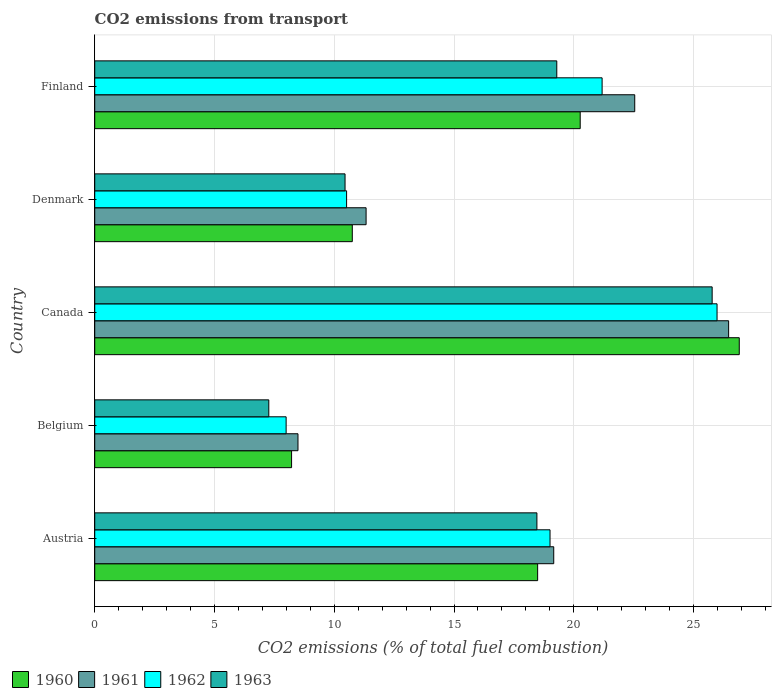How many different coloured bars are there?
Offer a very short reply. 4. Are the number of bars per tick equal to the number of legend labels?
Keep it short and to the point. Yes. Are the number of bars on each tick of the Y-axis equal?
Your answer should be very brief. Yes. What is the label of the 3rd group of bars from the top?
Your answer should be very brief. Canada. In how many cases, is the number of bars for a given country not equal to the number of legend labels?
Keep it short and to the point. 0. What is the total CO2 emitted in 1962 in Finland?
Provide a succinct answer. 21.18. Across all countries, what is the maximum total CO2 emitted in 1960?
Make the answer very short. 26.91. Across all countries, what is the minimum total CO2 emitted in 1962?
Your response must be concise. 7.99. In which country was the total CO2 emitted in 1961 minimum?
Your answer should be very brief. Belgium. What is the total total CO2 emitted in 1962 in the graph?
Provide a short and direct response. 84.67. What is the difference between the total CO2 emitted in 1961 in Austria and that in Denmark?
Provide a short and direct response. 7.83. What is the difference between the total CO2 emitted in 1963 in Austria and the total CO2 emitted in 1961 in Finland?
Ensure brevity in your answer.  -4.08. What is the average total CO2 emitted in 1961 per country?
Give a very brief answer. 17.6. What is the difference between the total CO2 emitted in 1963 and total CO2 emitted in 1960 in Finland?
Keep it short and to the point. -0.98. In how many countries, is the total CO2 emitted in 1963 greater than 26 ?
Make the answer very short. 0. What is the ratio of the total CO2 emitted in 1963 in Belgium to that in Denmark?
Provide a succinct answer. 0.7. Is the difference between the total CO2 emitted in 1963 in Belgium and Canada greater than the difference between the total CO2 emitted in 1960 in Belgium and Canada?
Ensure brevity in your answer.  Yes. What is the difference between the highest and the second highest total CO2 emitted in 1962?
Your response must be concise. 4.8. What is the difference between the highest and the lowest total CO2 emitted in 1963?
Give a very brief answer. 18.51. What does the 3rd bar from the bottom in Austria represents?
Provide a short and direct response. 1962. Is it the case that in every country, the sum of the total CO2 emitted in 1961 and total CO2 emitted in 1963 is greater than the total CO2 emitted in 1962?
Provide a succinct answer. Yes. How many bars are there?
Offer a very short reply. 20. Are all the bars in the graph horizontal?
Provide a succinct answer. Yes. How many countries are there in the graph?
Your answer should be very brief. 5. Does the graph contain any zero values?
Provide a short and direct response. No. Does the graph contain grids?
Provide a short and direct response. Yes. Where does the legend appear in the graph?
Provide a short and direct response. Bottom left. How are the legend labels stacked?
Provide a succinct answer. Horizontal. What is the title of the graph?
Offer a terse response. CO2 emissions from transport. Does "2000" appear as one of the legend labels in the graph?
Provide a short and direct response. No. What is the label or title of the X-axis?
Ensure brevity in your answer.  CO2 emissions (% of total fuel combustion). What is the CO2 emissions (% of total fuel combustion) in 1960 in Austria?
Give a very brief answer. 18.49. What is the CO2 emissions (% of total fuel combustion) in 1961 in Austria?
Offer a very short reply. 19.16. What is the CO2 emissions (% of total fuel combustion) in 1962 in Austria?
Ensure brevity in your answer.  19.01. What is the CO2 emissions (% of total fuel combustion) in 1963 in Austria?
Offer a terse response. 18.46. What is the CO2 emissions (% of total fuel combustion) in 1960 in Belgium?
Your answer should be very brief. 8.22. What is the CO2 emissions (% of total fuel combustion) of 1961 in Belgium?
Keep it short and to the point. 8.49. What is the CO2 emissions (% of total fuel combustion) in 1962 in Belgium?
Offer a very short reply. 7.99. What is the CO2 emissions (% of total fuel combustion) of 1963 in Belgium?
Provide a short and direct response. 7.27. What is the CO2 emissions (% of total fuel combustion) in 1960 in Canada?
Your answer should be compact. 26.91. What is the CO2 emissions (% of total fuel combustion) of 1961 in Canada?
Offer a very short reply. 26.46. What is the CO2 emissions (% of total fuel combustion) of 1962 in Canada?
Keep it short and to the point. 25.98. What is the CO2 emissions (% of total fuel combustion) of 1963 in Canada?
Your answer should be compact. 25.78. What is the CO2 emissions (% of total fuel combustion) of 1960 in Denmark?
Ensure brevity in your answer.  10.75. What is the CO2 emissions (% of total fuel combustion) of 1961 in Denmark?
Your response must be concise. 11.33. What is the CO2 emissions (% of total fuel combustion) in 1962 in Denmark?
Your answer should be very brief. 10.51. What is the CO2 emissions (% of total fuel combustion) of 1963 in Denmark?
Keep it short and to the point. 10.45. What is the CO2 emissions (% of total fuel combustion) in 1960 in Finland?
Make the answer very short. 20.27. What is the CO2 emissions (% of total fuel combustion) in 1961 in Finland?
Provide a succinct answer. 22.54. What is the CO2 emissions (% of total fuel combustion) in 1962 in Finland?
Offer a very short reply. 21.18. What is the CO2 emissions (% of total fuel combustion) of 1963 in Finland?
Offer a very short reply. 19.29. Across all countries, what is the maximum CO2 emissions (% of total fuel combustion) in 1960?
Offer a very short reply. 26.91. Across all countries, what is the maximum CO2 emissions (% of total fuel combustion) of 1961?
Provide a succinct answer. 26.46. Across all countries, what is the maximum CO2 emissions (% of total fuel combustion) in 1962?
Offer a very short reply. 25.98. Across all countries, what is the maximum CO2 emissions (% of total fuel combustion) of 1963?
Give a very brief answer. 25.78. Across all countries, what is the minimum CO2 emissions (% of total fuel combustion) of 1960?
Your response must be concise. 8.22. Across all countries, what is the minimum CO2 emissions (% of total fuel combustion) in 1961?
Make the answer very short. 8.49. Across all countries, what is the minimum CO2 emissions (% of total fuel combustion) in 1962?
Offer a terse response. 7.99. Across all countries, what is the minimum CO2 emissions (% of total fuel combustion) in 1963?
Your answer should be compact. 7.27. What is the total CO2 emissions (% of total fuel combustion) of 1960 in the graph?
Offer a very short reply. 84.64. What is the total CO2 emissions (% of total fuel combustion) of 1961 in the graph?
Keep it short and to the point. 87.98. What is the total CO2 emissions (% of total fuel combustion) in 1962 in the graph?
Keep it short and to the point. 84.67. What is the total CO2 emissions (% of total fuel combustion) in 1963 in the graph?
Ensure brevity in your answer.  81.24. What is the difference between the CO2 emissions (% of total fuel combustion) of 1960 in Austria and that in Belgium?
Offer a terse response. 10.27. What is the difference between the CO2 emissions (% of total fuel combustion) of 1961 in Austria and that in Belgium?
Your response must be concise. 10.68. What is the difference between the CO2 emissions (% of total fuel combustion) of 1962 in Austria and that in Belgium?
Provide a succinct answer. 11.02. What is the difference between the CO2 emissions (% of total fuel combustion) of 1963 in Austria and that in Belgium?
Your answer should be very brief. 11.19. What is the difference between the CO2 emissions (% of total fuel combustion) in 1960 in Austria and that in Canada?
Provide a succinct answer. -8.42. What is the difference between the CO2 emissions (% of total fuel combustion) of 1961 in Austria and that in Canada?
Your response must be concise. -7.3. What is the difference between the CO2 emissions (% of total fuel combustion) in 1962 in Austria and that in Canada?
Provide a short and direct response. -6.97. What is the difference between the CO2 emissions (% of total fuel combustion) of 1963 in Austria and that in Canada?
Make the answer very short. -7.32. What is the difference between the CO2 emissions (% of total fuel combustion) of 1960 in Austria and that in Denmark?
Offer a very short reply. 7.74. What is the difference between the CO2 emissions (% of total fuel combustion) in 1961 in Austria and that in Denmark?
Your response must be concise. 7.83. What is the difference between the CO2 emissions (% of total fuel combustion) of 1962 in Austria and that in Denmark?
Your answer should be compact. 8.49. What is the difference between the CO2 emissions (% of total fuel combustion) of 1963 in Austria and that in Denmark?
Your response must be concise. 8.01. What is the difference between the CO2 emissions (% of total fuel combustion) of 1960 in Austria and that in Finland?
Your answer should be very brief. -1.78. What is the difference between the CO2 emissions (% of total fuel combustion) in 1961 in Austria and that in Finland?
Offer a terse response. -3.38. What is the difference between the CO2 emissions (% of total fuel combustion) in 1962 in Austria and that in Finland?
Provide a succinct answer. -2.17. What is the difference between the CO2 emissions (% of total fuel combustion) of 1963 in Austria and that in Finland?
Give a very brief answer. -0.83. What is the difference between the CO2 emissions (% of total fuel combustion) in 1960 in Belgium and that in Canada?
Your response must be concise. -18.69. What is the difference between the CO2 emissions (% of total fuel combustion) in 1961 in Belgium and that in Canada?
Your answer should be compact. -17.98. What is the difference between the CO2 emissions (% of total fuel combustion) in 1962 in Belgium and that in Canada?
Make the answer very short. -17.99. What is the difference between the CO2 emissions (% of total fuel combustion) of 1963 in Belgium and that in Canada?
Give a very brief answer. -18.51. What is the difference between the CO2 emissions (% of total fuel combustion) of 1960 in Belgium and that in Denmark?
Keep it short and to the point. -2.53. What is the difference between the CO2 emissions (% of total fuel combustion) in 1961 in Belgium and that in Denmark?
Your answer should be compact. -2.84. What is the difference between the CO2 emissions (% of total fuel combustion) in 1962 in Belgium and that in Denmark?
Give a very brief answer. -2.52. What is the difference between the CO2 emissions (% of total fuel combustion) of 1963 in Belgium and that in Denmark?
Ensure brevity in your answer.  -3.18. What is the difference between the CO2 emissions (% of total fuel combustion) of 1960 in Belgium and that in Finland?
Keep it short and to the point. -12.05. What is the difference between the CO2 emissions (% of total fuel combustion) of 1961 in Belgium and that in Finland?
Give a very brief answer. -14.06. What is the difference between the CO2 emissions (% of total fuel combustion) in 1962 in Belgium and that in Finland?
Provide a succinct answer. -13.19. What is the difference between the CO2 emissions (% of total fuel combustion) in 1963 in Belgium and that in Finland?
Make the answer very short. -12.02. What is the difference between the CO2 emissions (% of total fuel combustion) of 1960 in Canada and that in Denmark?
Ensure brevity in your answer.  16.16. What is the difference between the CO2 emissions (% of total fuel combustion) of 1961 in Canada and that in Denmark?
Offer a very short reply. 15.13. What is the difference between the CO2 emissions (% of total fuel combustion) in 1962 in Canada and that in Denmark?
Your response must be concise. 15.47. What is the difference between the CO2 emissions (% of total fuel combustion) in 1963 in Canada and that in Denmark?
Your answer should be very brief. 15.33. What is the difference between the CO2 emissions (% of total fuel combustion) in 1960 in Canada and that in Finland?
Make the answer very short. 6.64. What is the difference between the CO2 emissions (% of total fuel combustion) of 1961 in Canada and that in Finland?
Provide a short and direct response. 3.92. What is the difference between the CO2 emissions (% of total fuel combustion) of 1962 in Canada and that in Finland?
Your answer should be compact. 4.8. What is the difference between the CO2 emissions (% of total fuel combustion) of 1963 in Canada and that in Finland?
Give a very brief answer. 6.49. What is the difference between the CO2 emissions (% of total fuel combustion) of 1960 in Denmark and that in Finland?
Give a very brief answer. -9.51. What is the difference between the CO2 emissions (% of total fuel combustion) in 1961 in Denmark and that in Finland?
Keep it short and to the point. -11.22. What is the difference between the CO2 emissions (% of total fuel combustion) in 1962 in Denmark and that in Finland?
Provide a succinct answer. -10.67. What is the difference between the CO2 emissions (% of total fuel combustion) in 1963 in Denmark and that in Finland?
Give a very brief answer. -8.84. What is the difference between the CO2 emissions (% of total fuel combustion) in 1960 in Austria and the CO2 emissions (% of total fuel combustion) in 1961 in Belgium?
Ensure brevity in your answer.  10. What is the difference between the CO2 emissions (% of total fuel combustion) in 1960 in Austria and the CO2 emissions (% of total fuel combustion) in 1962 in Belgium?
Offer a terse response. 10.5. What is the difference between the CO2 emissions (% of total fuel combustion) in 1960 in Austria and the CO2 emissions (% of total fuel combustion) in 1963 in Belgium?
Keep it short and to the point. 11.22. What is the difference between the CO2 emissions (% of total fuel combustion) of 1961 in Austria and the CO2 emissions (% of total fuel combustion) of 1962 in Belgium?
Ensure brevity in your answer.  11.17. What is the difference between the CO2 emissions (% of total fuel combustion) of 1961 in Austria and the CO2 emissions (% of total fuel combustion) of 1963 in Belgium?
Keep it short and to the point. 11.9. What is the difference between the CO2 emissions (% of total fuel combustion) of 1962 in Austria and the CO2 emissions (% of total fuel combustion) of 1963 in Belgium?
Your answer should be compact. 11.74. What is the difference between the CO2 emissions (% of total fuel combustion) of 1960 in Austria and the CO2 emissions (% of total fuel combustion) of 1961 in Canada?
Provide a short and direct response. -7.97. What is the difference between the CO2 emissions (% of total fuel combustion) in 1960 in Austria and the CO2 emissions (% of total fuel combustion) in 1962 in Canada?
Ensure brevity in your answer.  -7.49. What is the difference between the CO2 emissions (% of total fuel combustion) of 1960 in Austria and the CO2 emissions (% of total fuel combustion) of 1963 in Canada?
Give a very brief answer. -7.29. What is the difference between the CO2 emissions (% of total fuel combustion) in 1961 in Austria and the CO2 emissions (% of total fuel combustion) in 1962 in Canada?
Provide a succinct answer. -6.82. What is the difference between the CO2 emissions (% of total fuel combustion) in 1961 in Austria and the CO2 emissions (% of total fuel combustion) in 1963 in Canada?
Provide a succinct answer. -6.61. What is the difference between the CO2 emissions (% of total fuel combustion) of 1962 in Austria and the CO2 emissions (% of total fuel combustion) of 1963 in Canada?
Offer a very short reply. -6.77. What is the difference between the CO2 emissions (% of total fuel combustion) in 1960 in Austria and the CO2 emissions (% of total fuel combustion) in 1961 in Denmark?
Keep it short and to the point. 7.16. What is the difference between the CO2 emissions (% of total fuel combustion) of 1960 in Austria and the CO2 emissions (% of total fuel combustion) of 1962 in Denmark?
Make the answer very short. 7.98. What is the difference between the CO2 emissions (% of total fuel combustion) of 1960 in Austria and the CO2 emissions (% of total fuel combustion) of 1963 in Denmark?
Your response must be concise. 8.04. What is the difference between the CO2 emissions (% of total fuel combustion) in 1961 in Austria and the CO2 emissions (% of total fuel combustion) in 1962 in Denmark?
Give a very brief answer. 8.65. What is the difference between the CO2 emissions (% of total fuel combustion) of 1961 in Austria and the CO2 emissions (% of total fuel combustion) of 1963 in Denmark?
Provide a succinct answer. 8.71. What is the difference between the CO2 emissions (% of total fuel combustion) of 1962 in Austria and the CO2 emissions (% of total fuel combustion) of 1963 in Denmark?
Your answer should be very brief. 8.56. What is the difference between the CO2 emissions (% of total fuel combustion) of 1960 in Austria and the CO2 emissions (% of total fuel combustion) of 1961 in Finland?
Ensure brevity in your answer.  -4.05. What is the difference between the CO2 emissions (% of total fuel combustion) of 1960 in Austria and the CO2 emissions (% of total fuel combustion) of 1962 in Finland?
Offer a very short reply. -2.69. What is the difference between the CO2 emissions (% of total fuel combustion) of 1960 in Austria and the CO2 emissions (% of total fuel combustion) of 1963 in Finland?
Give a very brief answer. -0.8. What is the difference between the CO2 emissions (% of total fuel combustion) of 1961 in Austria and the CO2 emissions (% of total fuel combustion) of 1962 in Finland?
Your response must be concise. -2.02. What is the difference between the CO2 emissions (% of total fuel combustion) in 1961 in Austria and the CO2 emissions (% of total fuel combustion) in 1963 in Finland?
Make the answer very short. -0.13. What is the difference between the CO2 emissions (% of total fuel combustion) in 1962 in Austria and the CO2 emissions (% of total fuel combustion) in 1963 in Finland?
Your answer should be very brief. -0.28. What is the difference between the CO2 emissions (% of total fuel combustion) in 1960 in Belgium and the CO2 emissions (% of total fuel combustion) in 1961 in Canada?
Provide a short and direct response. -18.25. What is the difference between the CO2 emissions (% of total fuel combustion) in 1960 in Belgium and the CO2 emissions (% of total fuel combustion) in 1962 in Canada?
Provide a short and direct response. -17.76. What is the difference between the CO2 emissions (% of total fuel combustion) of 1960 in Belgium and the CO2 emissions (% of total fuel combustion) of 1963 in Canada?
Ensure brevity in your answer.  -17.56. What is the difference between the CO2 emissions (% of total fuel combustion) in 1961 in Belgium and the CO2 emissions (% of total fuel combustion) in 1962 in Canada?
Offer a very short reply. -17.5. What is the difference between the CO2 emissions (% of total fuel combustion) of 1961 in Belgium and the CO2 emissions (% of total fuel combustion) of 1963 in Canada?
Offer a very short reply. -17.29. What is the difference between the CO2 emissions (% of total fuel combustion) in 1962 in Belgium and the CO2 emissions (% of total fuel combustion) in 1963 in Canada?
Provide a short and direct response. -17.79. What is the difference between the CO2 emissions (% of total fuel combustion) in 1960 in Belgium and the CO2 emissions (% of total fuel combustion) in 1961 in Denmark?
Your response must be concise. -3.11. What is the difference between the CO2 emissions (% of total fuel combustion) of 1960 in Belgium and the CO2 emissions (% of total fuel combustion) of 1962 in Denmark?
Ensure brevity in your answer.  -2.3. What is the difference between the CO2 emissions (% of total fuel combustion) in 1960 in Belgium and the CO2 emissions (% of total fuel combustion) in 1963 in Denmark?
Provide a succinct answer. -2.23. What is the difference between the CO2 emissions (% of total fuel combustion) in 1961 in Belgium and the CO2 emissions (% of total fuel combustion) in 1962 in Denmark?
Ensure brevity in your answer.  -2.03. What is the difference between the CO2 emissions (% of total fuel combustion) in 1961 in Belgium and the CO2 emissions (% of total fuel combustion) in 1963 in Denmark?
Offer a terse response. -1.96. What is the difference between the CO2 emissions (% of total fuel combustion) in 1962 in Belgium and the CO2 emissions (% of total fuel combustion) in 1963 in Denmark?
Your answer should be very brief. -2.46. What is the difference between the CO2 emissions (% of total fuel combustion) in 1960 in Belgium and the CO2 emissions (% of total fuel combustion) in 1961 in Finland?
Offer a terse response. -14.33. What is the difference between the CO2 emissions (% of total fuel combustion) of 1960 in Belgium and the CO2 emissions (% of total fuel combustion) of 1962 in Finland?
Your response must be concise. -12.96. What is the difference between the CO2 emissions (% of total fuel combustion) of 1960 in Belgium and the CO2 emissions (% of total fuel combustion) of 1963 in Finland?
Make the answer very short. -11.07. What is the difference between the CO2 emissions (% of total fuel combustion) of 1961 in Belgium and the CO2 emissions (% of total fuel combustion) of 1962 in Finland?
Make the answer very short. -12.7. What is the difference between the CO2 emissions (% of total fuel combustion) of 1961 in Belgium and the CO2 emissions (% of total fuel combustion) of 1963 in Finland?
Your answer should be very brief. -10.8. What is the difference between the CO2 emissions (% of total fuel combustion) in 1962 in Belgium and the CO2 emissions (% of total fuel combustion) in 1963 in Finland?
Make the answer very short. -11.3. What is the difference between the CO2 emissions (% of total fuel combustion) of 1960 in Canada and the CO2 emissions (% of total fuel combustion) of 1961 in Denmark?
Give a very brief answer. 15.58. What is the difference between the CO2 emissions (% of total fuel combustion) in 1960 in Canada and the CO2 emissions (% of total fuel combustion) in 1962 in Denmark?
Your response must be concise. 16.39. What is the difference between the CO2 emissions (% of total fuel combustion) in 1960 in Canada and the CO2 emissions (% of total fuel combustion) in 1963 in Denmark?
Give a very brief answer. 16.46. What is the difference between the CO2 emissions (% of total fuel combustion) in 1961 in Canada and the CO2 emissions (% of total fuel combustion) in 1962 in Denmark?
Offer a terse response. 15.95. What is the difference between the CO2 emissions (% of total fuel combustion) in 1961 in Canada and the CO2 emissions (% of total fuel combustion) in 1963 in Denmark?
Offer a terse response. 16.01. What is the difference between the CO2 emissions (% of total fuel combustion) of 1962 in Canada and the CO2 emissions (% of total fuel combustion) of 1963 in Denmark?
Provide a short and direct response. 15.53. What is the difference between the CO2 emissions (% of total fuel combustion) in 1960 in Canada and the CO2 emissions (% of total fuel combustion) in 1961 in Finland?
Your answer should be very brief. 4.36. What is the difference between the CO2 emissions (% of total fuel combustion) of 1960 in Canada and the CO2 emissions (% of total fuel combustion) of 1962 in Finland?
Offer a terse response. 5.73. What is the difference between the CO2 emissions (% of total fuel combustion) in 1960 in Canada and the CO2 emissions (% of total fuel combustion) in 1963 in Finland?
Keep it short and to the point. 7.62. What is the difference between the CO2 emissions (% of total fuel combustion) of 1961 in Canada and the CO2 emissions (% of total fuel combustion) of 1962 in Finland?
Your answer should be very brief. 5.28. What is the difference between the CO2 emissions (% of total fuel combustion) in 1961 in Canada and the CO2 emissions (% of total fuel combustion) in 1963 in Finland?
Provide a short and direct response. 7.17. What is the difference between the CO2 emissions (% of total fuel combustion) of 1962 in Canada and the CO2 emissions (% of total fuel combustion) of 1963 in Finland?
Give a very brief answer. 6.69. What is the difference between the CO2 emissions (% of total fuel combustion) of 1960 in Denmark and the CO2 emissions (% of total fuel combustion) of 1961 in Finland?
Offer a very short reply. -11.79. What is the difference between the CO2 emissions (% of total fuel combustion) of 1960 in Denmark and the CO2 emissions (% of total fuel combustion) of 1962 in Finland?
Your answer should be very brief. -10.43. What is the difference between the CO2 emissions (% of total fuel combustion) in 1960 in Denmark and the CO2 emissions (% of total fuel combustion) in 1963 in Finland?
Your answer should be compact. -8.54. What is the difference between the CO2 emissions (% of total fuel combustion) of 1961 in Denmark and the CO2 emissions (% of total fuel combustion) of 1962 in Finland?
Offer a very short reply. -9.85. What is the difference between the CO2 emissions (% of total fuel combustion) of 1961 in Denmark and the CO2 emissions (% of total fuel combustion) of 1963 in Finland?
Ensure brevity in your answer.  -7.96. What is the difference between the CO2 emissions (% of total fuel combustion) of 1962 in Denmark and the CO2 emissions (% of total fuel combustion) of 1963 in Finland?
Make the answer very short. -8.78. What is the average CO2 emissions (% of total fuel combustion) in 1960 per country?
Your response must be concise. 16.93. What is the average CO2 emissions (% of total fuel combustion) in 1961 per country?
Provide a succinct answer. 17.6. What is the average CO2 emissions (% of total fuel combustion) of 1962 per country?
Make the answer very short. 16.93. What is the average CO2 emissions (% of total fuel combustion) in 1963 per country?
Your response must be concise. 16.25. What is the difference between the CO2 emissions (% of total fuel combustion) in 1960 and CO2 emissions (% of total fuel combustion) in 1961 in Austria?
Ensure brevity in your answer.  -0.67. What is the difference between the CO2 emissions (% of total fuel combustion) of 1960 and CO2 emissions (% of total fuel combustion) of 1962 in Austria?
Provide a succinct answer. -0.52. What is the difference between the CO2 emissions (% of total fuel combustion) in 1960 and CO2 emissions (% of total fuel combustion) in 1963 in Austria?
Provide a short and direct response. 0.03. What is the difference between the CO2 emissions (% of total fuel combustion) in 1961 and CO2 emissions (% of total fuel combustion) in 1962 in Austria?
Make the answer very short. 0.15. What is the difference between the CO2 emissions (% of total fuel combustion) in 1961 and CO2 emissions (% of total fuel combustion) in 1963 in Austria?
Your response must be concise. 0.7. What is the difference between the CO2 emissions (% of total fuel combustion) in 1962 and CO2 emissions (% of total fuel combustion) in 1963 in Austria?
Keep it short and to the point. 0.55. What is the difference between the CO2 emissions (% of total fuel combustion) of 1960 and CO2 emissions (% of total fuel combustion) of 1961 in Belgium?
Ensure brevity in your answer.  -0.27. What is the difference between the CO2 emissions (% of total fuel combustion) of 1960 and CO2 emissions (% of total fuel combustion) of 1962 in Belgium?
Your response must be concise. 0.23. What is the difference between the CO2 emissions (% of total fuel combustion) in 1960 and CO2 emissions (% of total fuel combustion) in 1963 in Belgium?
Provide a succinct answer. 0.95. What is the difference between the CO2 emissions (% of total fuel combustion) of 1961 and CO2 emissions (% of total fuel combustion) of 1962 in Belgium?
Make the answer very short. 0.49. What is the difference between the CO2 emissions (% of total fuel combustion) in 1961 and CO2 emissions (% of total fuel combustion) in 1963 in Belgium?
Provide a succinct answer. 1.22. What is the difference between the CO2 emissions (% of total fuel combustion) in 1962 and CO2 emissions (% of total fuel combustion) in 1963 in Belgium?
Provide a succinct answer. 0.72. What is the difference between the CO2 emissions (% of total fuel combustion) of 1960 and CO2 emissions (% of total fuel combustion) of 1961 in Canada?
Your answer should be very brief. 0.44. What is the difference between the CO2 emissions (% of total fuel combustion) of 1960 and CO2 emissions (% of total fuel combustion) of 1962 in Canada?
Your answer should be compact. 0.93. What is the difference between the CO2 emissions (% of total fuel combustion) of 1960 and CO2 emissions (% of total fuel combustion) of 1963 in Canada?
Offer a terse response. 1.13. What is the difference between the CO2 emissions (% of total fuel combustion) of 1961 and CO2 emissions (% of total fuel combustion) of 1962 in Canada?
Make the answer very short. 0.48. What is the difference between the CO2 emissions (% of total fuel combustion) of 1961 and CO2 emissions (% of total fuel combustion) of 1963 in Canada?
Make the answer very short. 0.69. What is the difference between the CO2 emissions (% of total fuel combustion) in 1962 and CO2 emissions (% of total fuel combustion) in 1963 in Canada?
Keep it short and to the point. 0.2. What is the difference between the CO2 emissions (% of total fuel combustion) in 1960 and CO2 emissions (% of total fuel combustion) in 1961 in Denmark?
Provide a succinct answer. -0.58. What is the difference between the CO2 emissions (% of total fuel combustion) of 1960 and CO2 emissions (% of total fuel combustion) of 1962 in Denmark?
Keep it short and to the point. 0.24. What is the difference between the CO2 emissions (% of total fuel combustion) of 1960 and CO2 emissions (% of total fuel combustion) of 1963 in Denmark?
Your answer should be very brief. 0.3. What is the difference between the CO2 emissions (% of total fuel combustion) in 1961 and CO2 emissions (% of total fuel combustion) in 1962 in Denmark?
Your answer should be very brief. 0.81. What is the difference between the CO2 emissions (% of total fuel combustion) in 1961 and CO2 emissions (% of total fuel combustion) in 1963 in Denmark?
Your response must be concise. 0.88. What is the difference between the CO2 emissions (% of total fuel combustion) in 1962 and CO2 emissions (% of total fuel combustion) in 1963 in Denmark?
Your answer should be very brief. 0.06. What is the difference between the CO2 emissions (% of total fuel combustion) in 1960 and CO2 emissions (% of total fuel combustion) in 1961 in Finland?
Your answer should be very brief. -2.28. What is the difference between the CO2 emissions (% of total fuel combustion) in 1960 and CO2 emissions (% of total fuel combustion) in 1962 in Finland?
Make the answer very short. -0.91. What is the difference between the CO2 emissions (% of total fuel combustion) of 1960 and CO2 emissions (% of total fuel combustion) of 1963 in Finland?
Your answer should be very brief. 0.98. What is the difference between the CO2 emissions (% of total fuel combustion) of 1961 and CO2 emissions (% of total fuel combustion) of 1962 in Finland?
Provide a short and direct response. 1.36. What is the difference between the CO2 emissions (% of total fuel combustion) in 1961 and CO2 emissions (% of total fuel combustion) in 1963 in Finland?
Give a very brief answer. 3.25. What is the difference between the CO2 emissions (% of total fuel combustion) in 1962 and CO2 emissions (% of total fuel combustion) in 1963 in Finland?
Your answer should be compact. 1.89. What is the ratio of the CO2 emissions (% of total fuel combustion) of 1960 in Austria to that in Belgium?
Your answer should be very brief. 2.25. What is the ratio of the CO2 emissions (% of total fuel combustion) in 1961 in Austria to that in Belgium?
Your answer should be very brief. 2.26. What is the ratio of the CO2 emissions (% of total fuel combustion) of 1962 in Austria to that in Belgium?
Offer a terse response. 2.38. What is the ratio of the CO2 emissions (% of total fuel combustion) in 1963 in Austria to that in Belgium?
Offer a very short reply. 2.54. What is the ratio of the CO2 emissions (% of total fuel combustion) of 1960 in Austria to that in Canada?
Provide a succinct answer. 0.69. What is the ratio of the CO2 emissions (% of total fuel combustion) of 1961 in Austria to that in Canada?
Offer a terse response. 0.72. What is the ratio of the CO2 emissions (% of total fuel combustion) in 1962 in Austria to that in Canada?
Provide a succinct answer. 0.73. What is the ratio of the CO2 emissions (% of total fuel combustion) in 1963 in Austria to that in Canada?
Your answer should be compact. 0.72. What is the ratio of the CO2 emissions (% of total fuel combustion) in 1960 in Austria to that in Denmark?
Make the answer very short. 1.72. What is the ratio of the CO2 emissions (% of total fuel combustion) in 1961 in Austria to that in Denmark?
Offer a very short reply. 1.69. What is the ratio of the CO2 emissions (% of total fuel combustion) in 1962 in Austria to that in Denmark?
Make the answer very short. 1.81. What is the ratio of the CO2 emissions (% of total fuel combustion) in 1963 in Austria to that in Denmark?
Offer a very short reply. 1.77. What is the ratio of the CO2 emissions (% of total fuel combustion) in 1960 in Austria to that in Finland?
Offer a very short reply. 0.91. What is the ratio of the CO2 emissions (% of total fuel combustion) in 1962 in Austria to that in Finland?
Give a very brief answer. 0.9. What is the ratio of the CO2 emissions (% of total fuel combustion) of 1963 in Austria to that in Finland?
Make the answer very short. 0.96. What is the ratio of the CO2 emissions (% of total fuel combustion) of 1960 in Belgium to that in Canada?
Keep it short and to the point. 0.31. What is the ratio of the CO2 emissions (% of total fuel combustion) in 1961 in Belgium to that in Canada?
Ensure brevity in your answer.  0.32. What is the ratio of the CO2 emissions (% of total fuel combustion) of 1962 in Belgium to that in Canada?
Offer a very short reply. 0.31. What is the ratio of the CO2 emissions (% of total fuel combustion) in 1963 in Belgium to that in Canada?
Your answer should be very brief. 0.28. What is the ratio of the CO2 emissions (% of total fuel combustion) of 1960 in Belgium to that in Denmark?
Your answer should be very brief. 0.76. What is the ratio of the CO2 emissions (% of total fuel combustion) in 1961 in Belgium to that in Denmark?
Keep it short and to the point. 0.75. What is the ratio of the CO2 emissions (% of total fuel combustion) of 1962 in Belgium to that in Denmark?
Your answer should be compact. 0.76. What is the ratio of the CO2 emissions (% of total fuel combustion) of 1963 in Belgium to that in Denmark?
Your answer should be very brief. 0.7. What is the ratio of the CO2 emissions (% of total fuel combustion) in 1960 in Belgium to that in Finland?
Your response must be concise. 0.41. What is the ratio of the CO2 emissions (% of total fuel combustion) of 1961 in Belgium to that in Finland?
Make the answer very short. 0.38. What is the ratio of the CO2 emissions (% of total fuel combustion) of 1962 in Belgium to that in Finland?
Your answer should be very brief. 0.38. What is the ratio of the CO2 emissions (% of total fuel combustion) of 1963 in Belgium to that in Finland?
Offer a terse response. 0.38. What is the ratio of the CO2 emissions (% of total fuel combustion) of 1960 in Canada to that in Denmark?
Keep it short and to the point. 2.5. What is the ratio of the CO2 emissions (% of total fuel combustion) of 1961 in Canada to that in Denmark?
Provide a succinct answer. 2.34. What is the ratio of the CO2 emissions (% of total fuel combustion) in 1962 in Canada to that in Denmark?
Give a very brief answer. 2.47. What is the ratio of the CO2 emissions (% of total fuel combustion) in 1963 in Canada to that in Denmark?
Keep it short and to the point. 2.47. What is the ratio of the CO2 emissions (% of total fuel combustion) of 1960 in Canada to that in Finland?
Provide a short and direct response. 1.33. What is the ratio of the CO2 emissions (% of total fuel combustion) in 1961 in Canada to that in Finland?
Make the answer very short. 1.17. What is the ratio of the CO2 emissions (% of total fuel combustion) of 1962 in Canada to that in Finland?
Provide a succinct answer. 1.23. What is the ratio of the CO2 emissions (% of total fuel combustion) of 1963 in Canada to that in Finland?
Offer a terse response. 1.34. What is the ratio of the CO2 emissions (% of total fuel combustion) of 1960 in Denmark to that in Finland?
Give a very brief answer. 0.53. What is the ratio of the CO2 emissions (% of total fuel combustion) of 1961 in Denmark to that in Finland?
Ensure brevity in your answer.  0.5. What is the ratio of the CO2 emissions (% of total fuel combustion) of 1962 in Denmark to that in Finland?
Keep it short and to the point. 0.5. What is the ratio of the CO2 emissions (% of total fuel combustion) of 1963 in Denmark to that in Finland?
Give a very brief answer. 0.54. What is the difference between the highest and the second highest CO2 emissions (% of total fuel combustion) in 1960?
Make the answer very short. 6.64. What is the difference between the highest and the second highest CO2 emissions (% of total fuel combustion) of 1961?
Make the answer very short. 3.92. What is the difference between the highest and the second highest CO2 emissions (% of total fuel combustion) of 1962?
Offer a terse response. 4.8. What is the difference between the highest and the second highest CO2 emissions (% of total fuel combustion) of 1963?
Keep it short and to the point. 6.49. What is the difference between the highest and the lowest CO2 emissions (% of total fuel combustion) of 1960?
Ensure brevity in your answer.  18.69. What is the difference between the highest and the lowest CO2 emissions (% of total fuel combustion) in 1961?
Offer a very short reply. 17.98. What is the difference between the highest and the lowest CO2 emissions (% of total fuel combustion) in 1962?
Your answer should be very brief. 17.99. What is the difference between the highest and the lowest CO2 emissions (% of total fuel combustion) of 1963?
Your response must be concise. 18.51. 